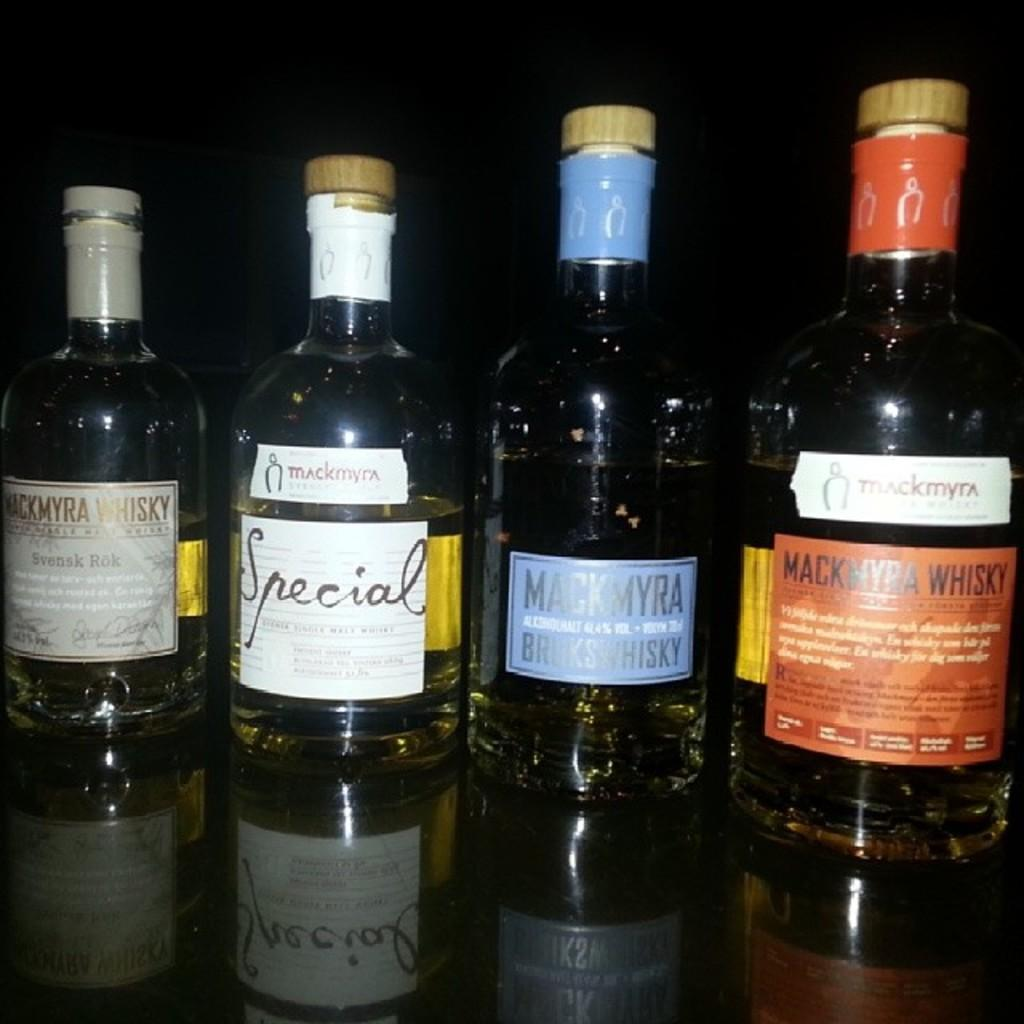How many bottles are on the table in the image? There are four bottles on the table in the image. What is inside each of the bottles? Each bottle contains a liquid. What advice does the ladybug on the island give to the bottles in the image? There is no ladybug or island present in the image, so no advice can be given. 